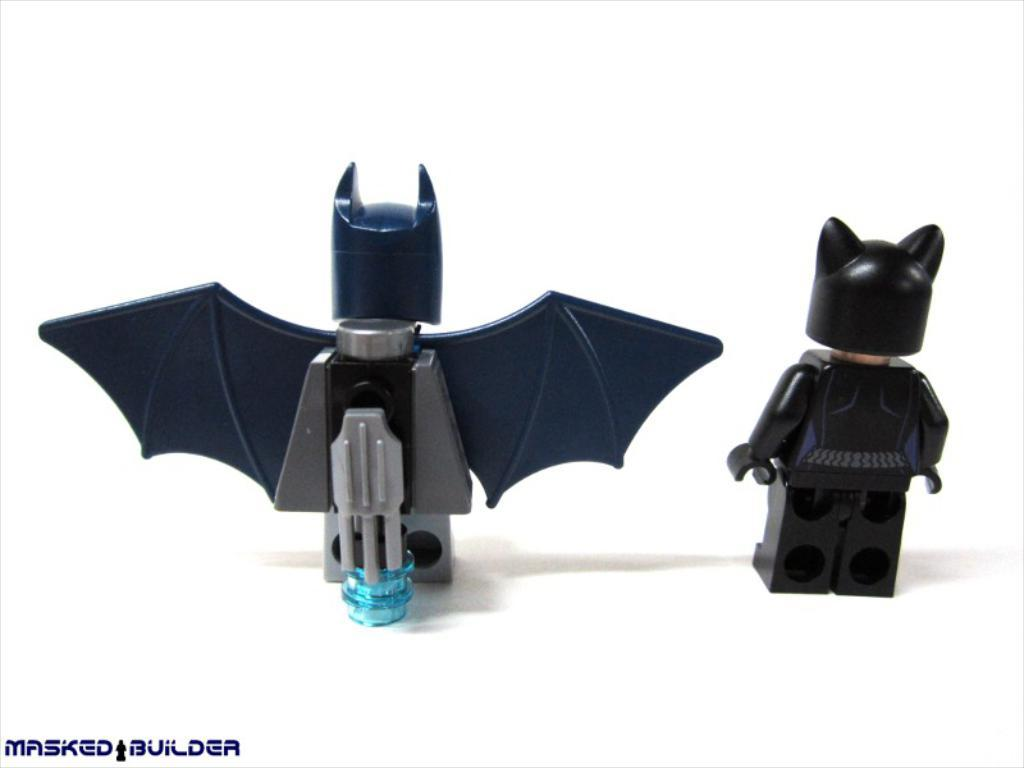What objects can be seen in the image? There are toys in the image. Where is the text located in the image? The text is located in the bottom left hand corner of the image. Can you see the brother playing with the toys in the image? There is no brother present in the image, only toys can be seen. What type of twig is being used as a toy in the image? There is no twig present in the image; only toys are visible. 